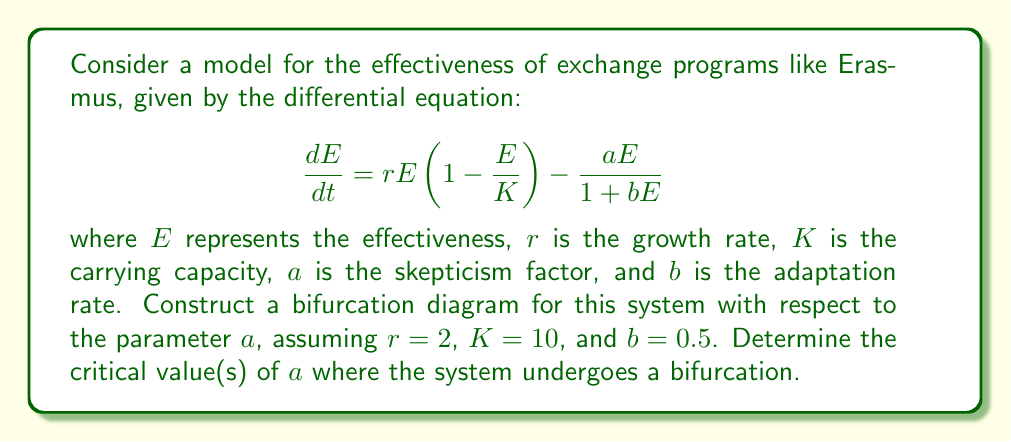Could you help me with this problem? To construct the bifurcation diagram and find the critical value(s) of $a$, we follow these steps:

1) First, find the equilibrium points by setting $\frac{dE}{dt} = 0$:

   $$rE(1-\frac{E}{K}) - \frac{aE}{1+bE} = 0$$

2) Simplify the equation:

   $$2E(1-\frac{E}{10}) - \frac{aE}{1+0.5E} = 0$$

3) Multiply both sides by $(1+0.5E)$:

   $$2E(1-\frac{E}{10})(1+0.5E) - aE = 0$$

4) Expand the equation:

   $$2E + E^2 - 0.2E^2 - 0.1E^3 - aE = 0$$

5) Rearrange to standard cubic form:

   $$-0.1E^3 + 0.8E^2 + (2-a)E = 0$$

6) Factor out $E$:

   $$E(-0.1E^2 + 0.8E + (2-a)) = 0$$

7) The equilibrium points are $E=0$ and the roots of $-0.1E^2 + 0.8E + (2-a) = 0$

8) Use the quadratic formula to find these roots:

   $$E = \frac{-0.8 \pm \sqrt{0.64 + 0.4(2-a)}}{-0.2}$$

9) The discriminant is $0.64 + 0.4(2-a)$. The bifurcation occurs when this equals zero:

   $$0.64 + 0.4(2-a) = 0$$
   $$0.64 + 0.8 - 0.4a = 0$$
   $$1.44 - 0.4a = 0$$
   $$a = 3.6$$

10) For $a < 3.6$, there are two positive equilibrium points besides $E=0$. For $a > 3.6$, $E=0$ is the only real equilibrium point.

The bifurcation diagram would show three branches for $a < 3.6$: one at $E=0$ and two positive branches that meet at $a = 3.6$. For $a > 3.6$, only the $E=0$ branch remains.
Answer: Bifurcation occurs at $a = 3.6$ 